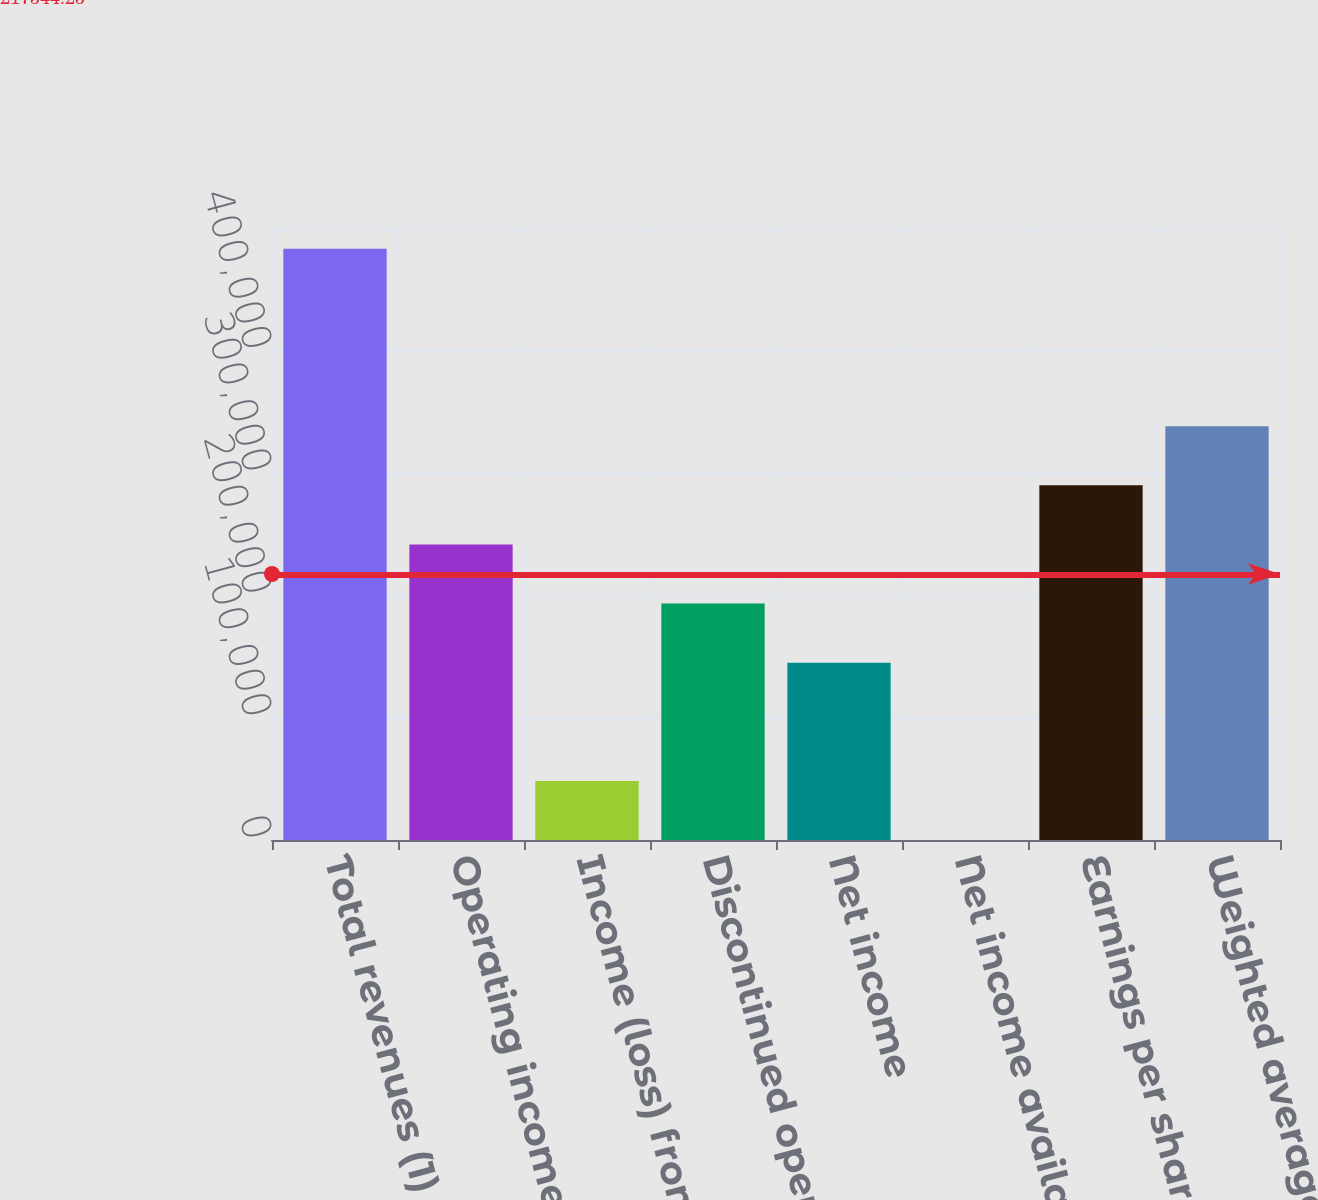Convert chart. <chart><loc_0><loc_0><loc_500><loc_500><bar_chart><fcel>Total revenues (1)<fcel>Operating income (1)<fcel>Income (loss) from continuing<fcel>Discontinued operations net<fcel>Net income<fcel>Net income available to Common<fcel>Earnings per share - diluted<fcel>Weighted average Common Shares<nl><fcel>482987<fcel>241494<fcel>48298.8<fcel>193195<fcel>144896<fcel>0.15<fcel>289792<fcel>338091<nl></chart> 